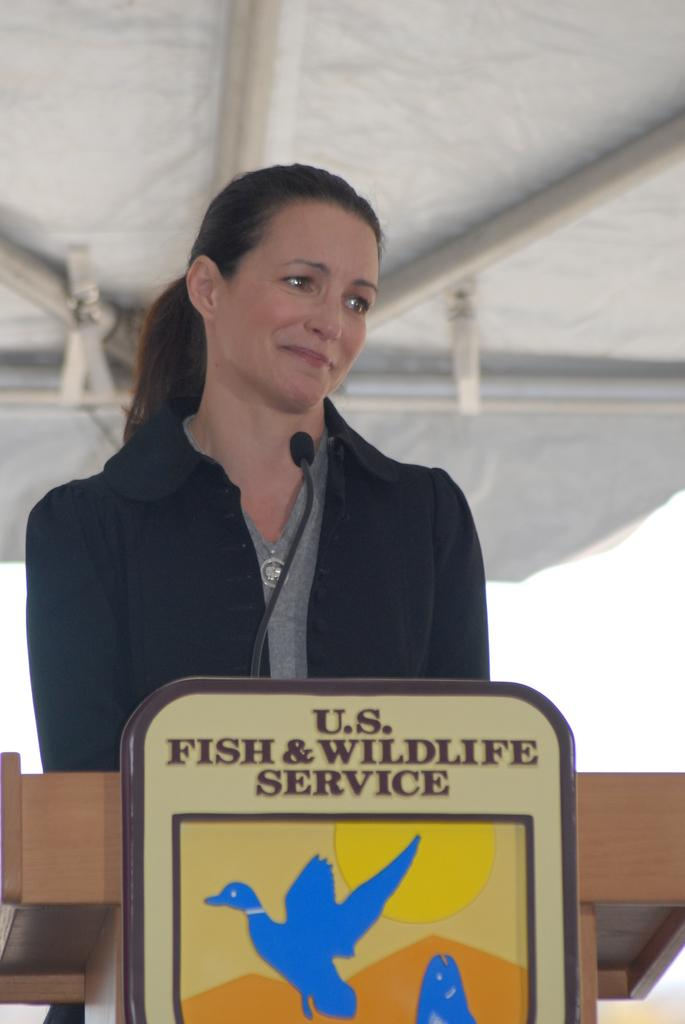<image>
Offer a succinct explanation of the picture presented. Woman looking at someone and tearing up behind a podium that says Fish & Wildlife Service. 